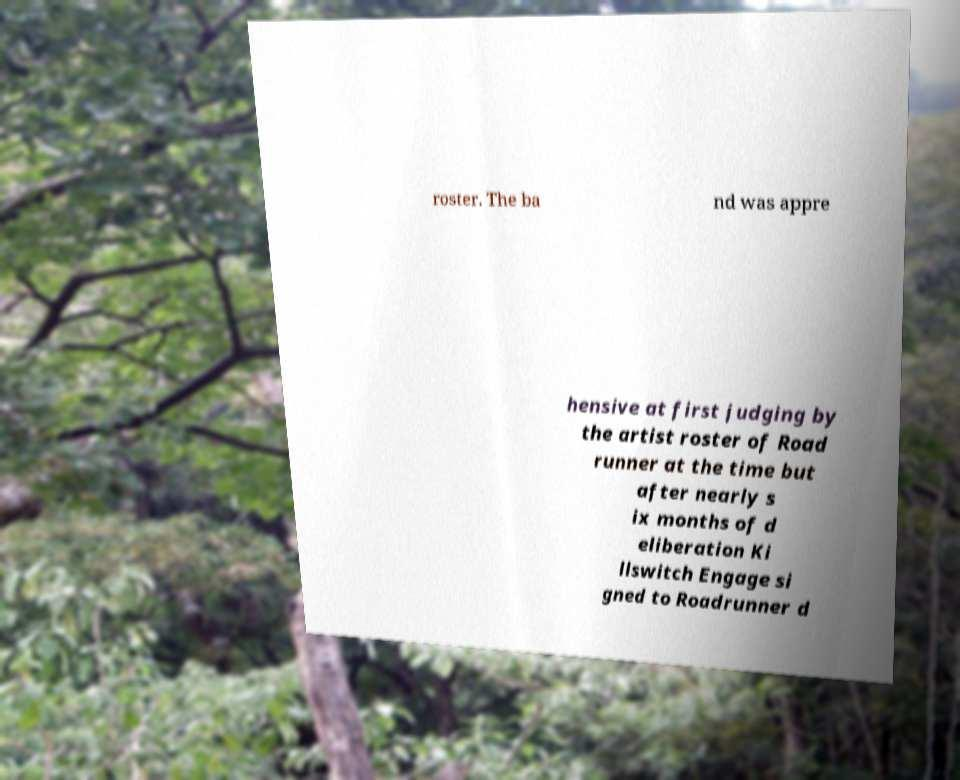Can you accurately transcribe the text from the provided image for me? roster. The ba nd was appre hensive at first judging by the artist roster of Road runner at the time but after nearly s ix months of d eliberation Ki llswitch Engage si gned to Roadrunner d 